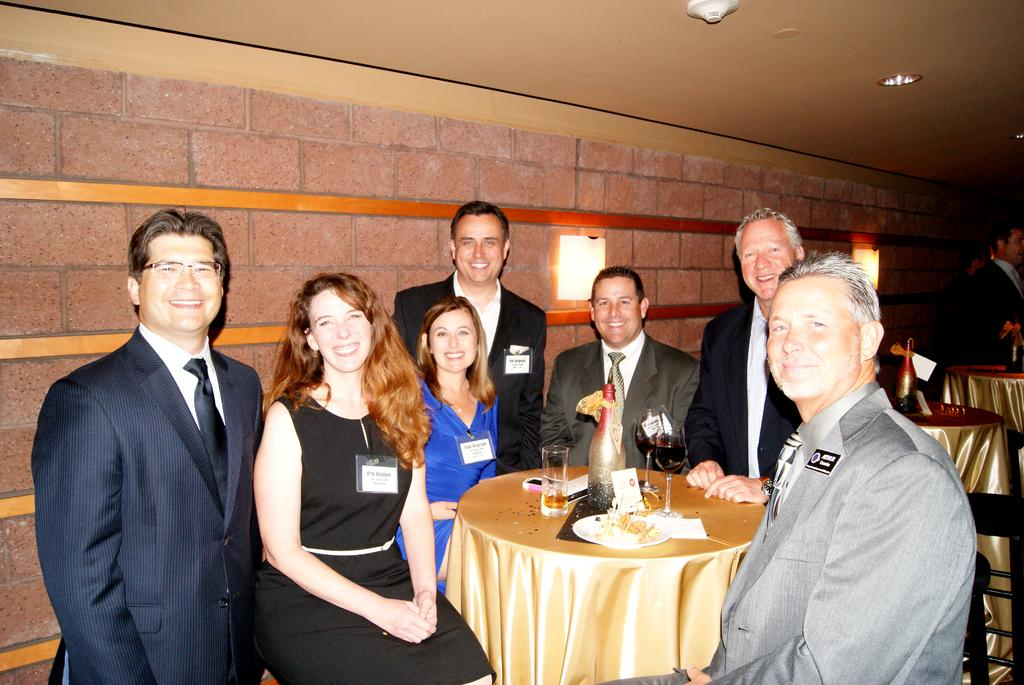How many people are in the image? There is a group of people in the image. What expression do the people in the image have? The group of people are holding smiles. What is present on the table in the image? There is a bottle, a card, a plate, and glasses on the table. How many robins are sitting on the plate in the image? There are no robins present in the image; the plate is empty. Can you tell me the name of the person holding the card in the image? The provided facts do not mention any names or specific individuals in the image. 